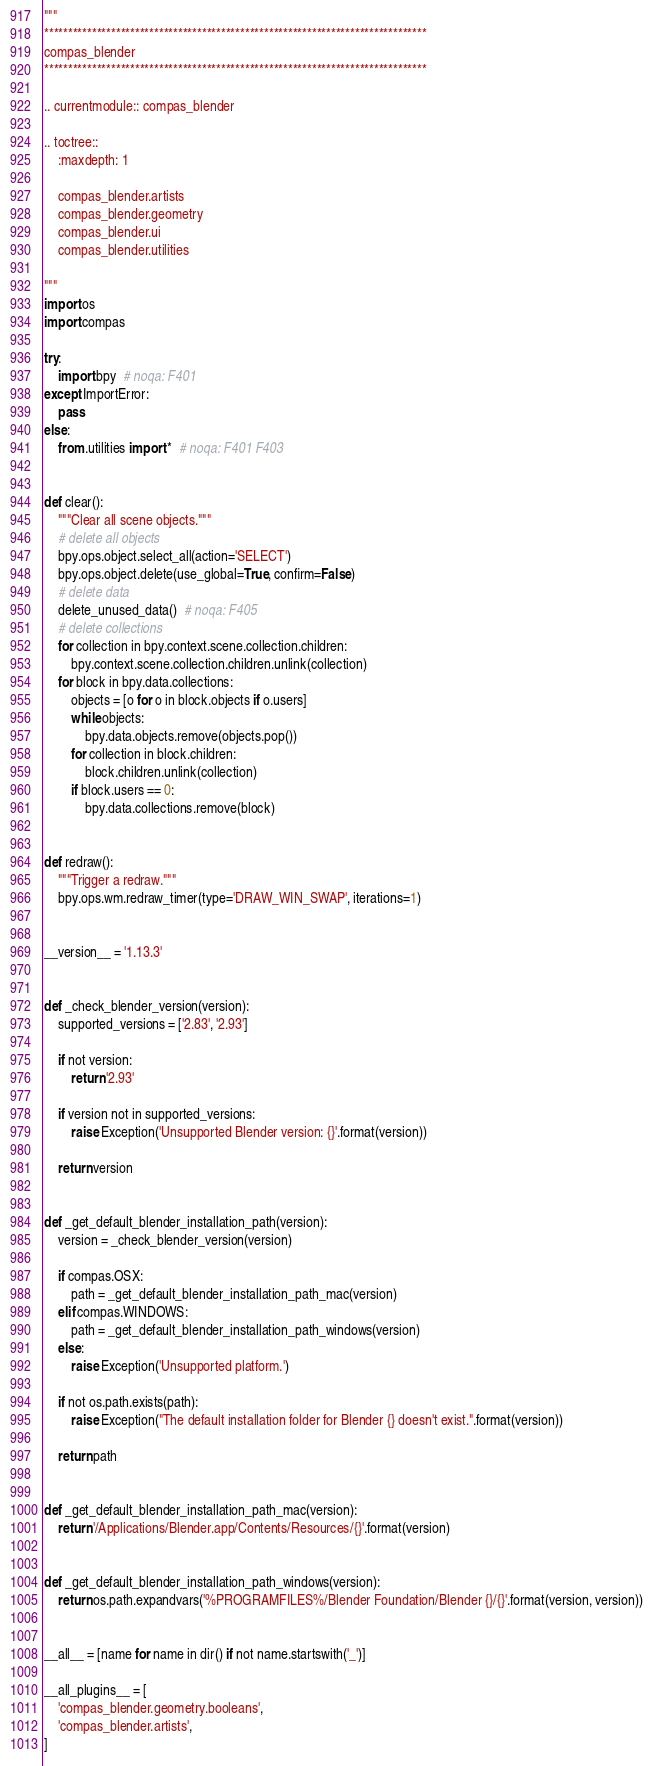Convert code to text. <code><loc_0><loc_0><loc_500><loc_500><_Python_>"""
********************************************************************************
compas_blender
********************************************************************************

.. currentmodule:: compas_blender

.. toctree::
    :maxdepth: 1

    compas_blender.artists
    compas_blender.geometry
    compas_blender.ui
    compas_blender.utilities

"""
import os
import compas

try:
    import bpy  # noqa: F401
except ImportError:
    pass
else:
    from .utilities import *  # noqa: F401 F403


def clear():
    """Clear all scene objects."""
    # delete all objects
    bpy.ops.object.select_all(action='SELECT')
    bpy.ops.object.delete(use_global=True, confirm=False)
    # delete data
    delete_unused_data()  # noqa: F405
    # delete collections
    for collection in bpy.context.scene.collection.children:
        bpy.context.scene.collection.children.unlink(collection)
    for block in bpy.data.collections:
        objects = [o for o in block.objects if o.users]
        while objects:
            bpy.data.objects.remove(objects.pop())
        for collection in block.children:
            block.children.unlink(collection)
        if block.users == 0:
            bpy.data.collections.remove(block)


def redraw():
    """Trigger a redraw."""
    bpy.ops.wm.redraw_timer(type='DRAW_WIN_SWAP', iterations=1)


__version__ = '1.13.3'


def _check_blender_version(version):
    supported_versions = ['2.83', '2.93']

    if not version:
        return '2.93'

    if version not in supported_versions:
        raise Exception('Unsupported Blender version: {}'.format(version))

    return version


def _get_default_blender_installation_path(version):
    version = _check_blender_version(version)

    if compas.OSX:
        path = _get_default_blender_installation_path_mac(version)
    elif compas.WINDOWS:
        path = _get_default_blender_installation_path_windows(version)
    else:
        raise Exception('Unsupported platform.')

    if not os.path.exists(path):
        raise Exception("The default installation folder for Blender {} doesn't exist.".format(version))

    return path


def _get_default_blender_installation_path_mac(version):
    return '/Applications/Blender.app/Contents/Resources/{}'.format(version)


def _get_default_blender_installation_path_windows(version):
    return os.path.expandvars('%PROGRAMFILES%/Blender Foundation/Blender {}/{}'.format(version, version))


__all__ = [name for name in dir() if not name.startswith('_')]

__all_plugins__ = [
    'compas_blender.geometry.booleans',
    'compas_blender.artists',
]
</code> 